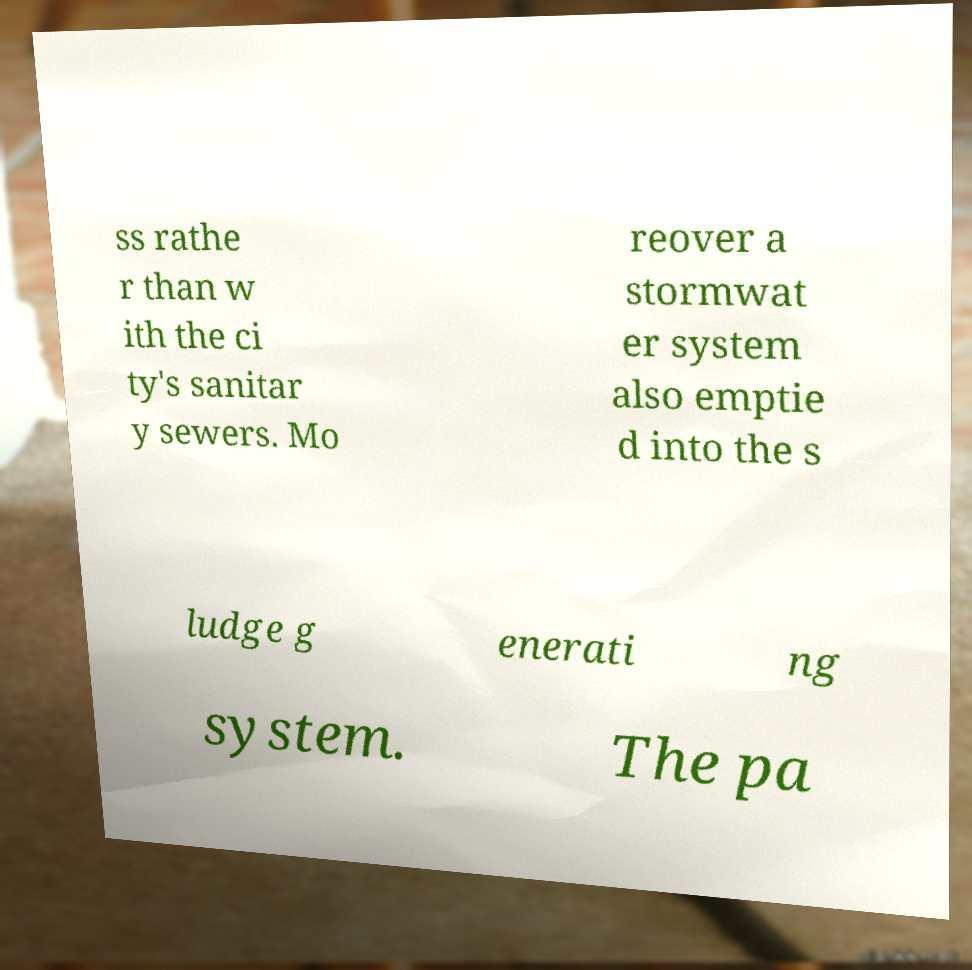There's text embedded in this image that I need extracted. Can you transcribe it verbatim? ss rathe r than w ith the ci ty's sanitar y sewers. Mo reover a stormwat er system also emptie d into the s ludge g enerati ng system. The pa 